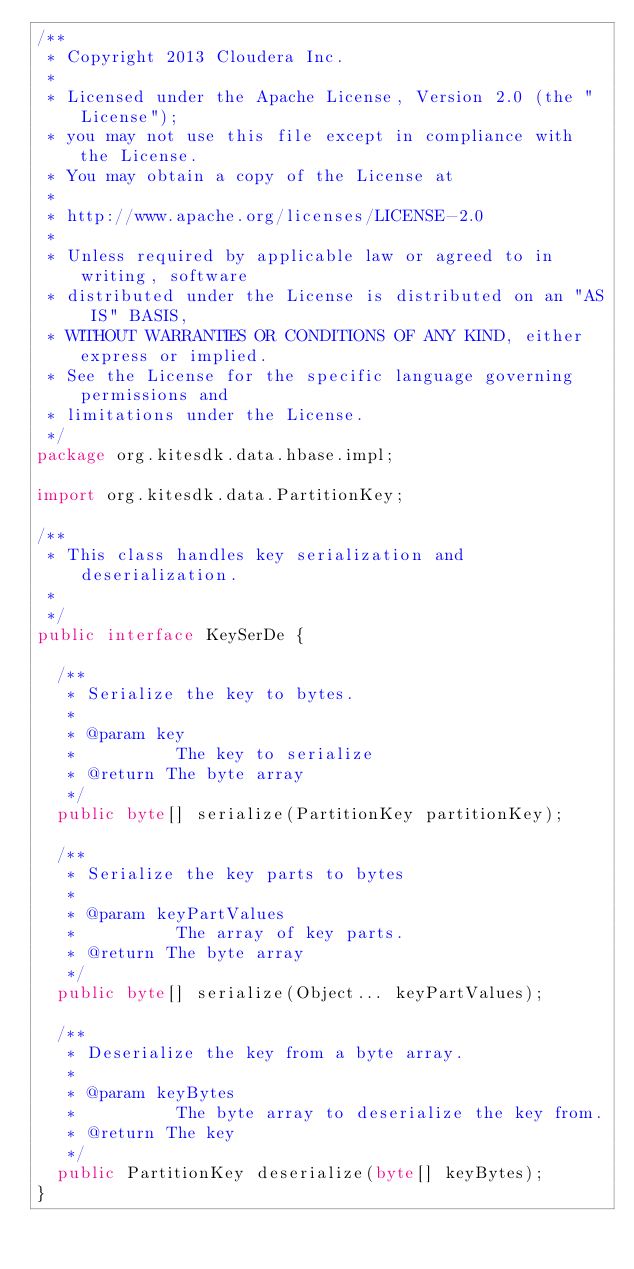<code> <loc_0><loc_0><loc_500><loc_500><_Java_>/**
 * Copyright 2013 Cloudera Inc.
 *
 * Licensed under the Apache License, Version 2.0 (the "License");
 * you may not use this file except in compliance with the License.
 * You may obtain a copy of the License at
 *
 * http://www.apache.org/licenses/LICENSE-2.0
 *
 * Unless required by applicable law or agreed to in writing, software
 * distributed under the License is distributed on an "AS IS" BASIS,
 * WITHOUT WARRANTIES OR CONDITIONS OF ANY KIND, either express or implied.
 * See the License for the specific language governing permissions and
 * limitations under the License.
 */
package org.kitesdk.data.hbase.impl;

import org.kitesdk.data.PartitionKey;

/**
 * This class handles key serialization and deserialization.
 * 
 */
public interface KeySerDe {

  /**
   * Serialize the key to bytes.
   * 
   * @param key
   *          The key to serialize
   * @return The byte array
   */
  public byte[] serialize(PartitionKey partitionKey);

  /**
   * Serialize the key parts to bytes
   *
   * @param keyPartValues
   *          The array of key parts.
   * @return The byte array
   */
  public byte[] serialize(Object... keyPartValues);

  /**
   * Deserialize the key from a byte array.
   * 
   * @param keyBytes
   *          The byte array to deserialize the key from.
   * @return The key
   */
  public PartitionKey deserialize(byte[] keyBytes);
}
</code> 